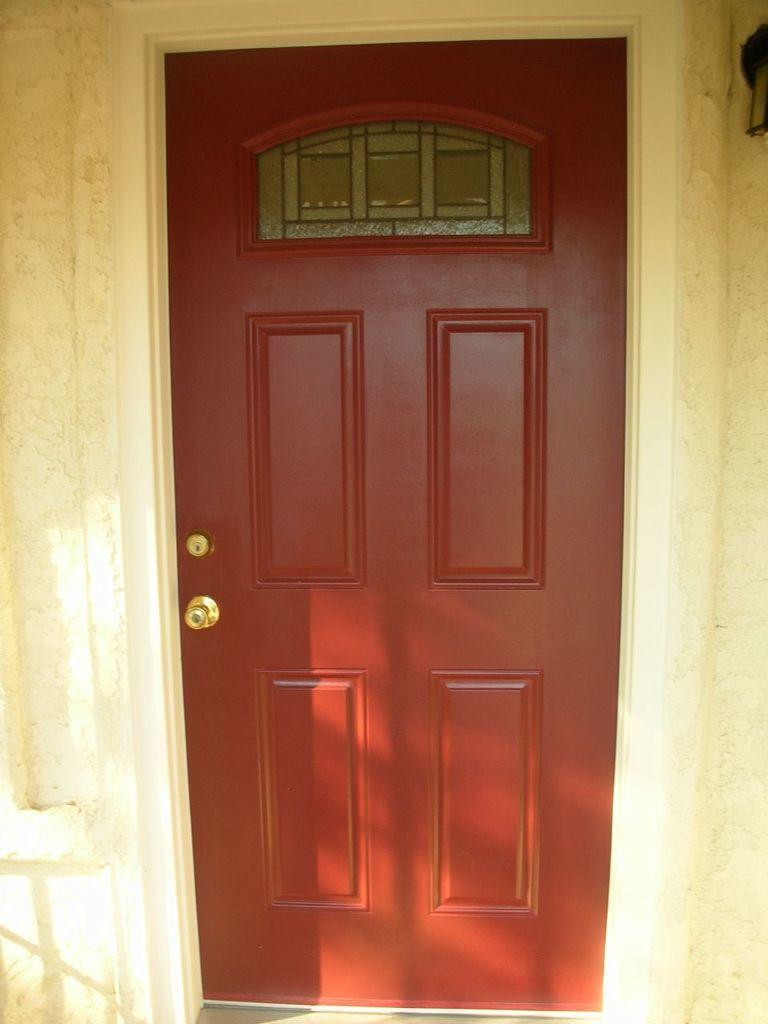What is the main subject of the image? The image appears to depict a front door. What type of offer is the sister making at the front door in the image? There is no sister present in the image, and therefore no offer can be observed. 